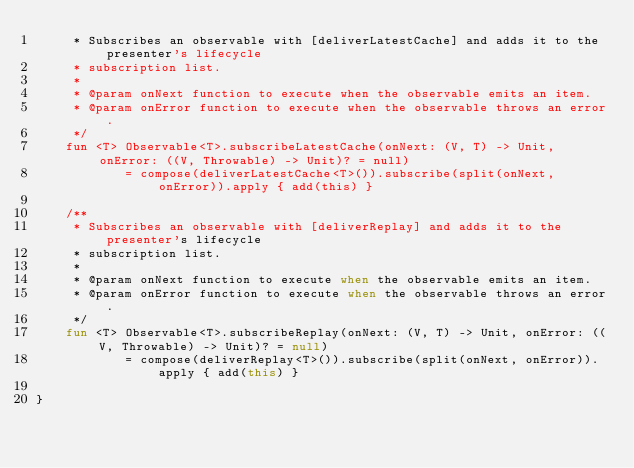Convert code to text. <code><loc_0><loc_0><loc_500><loc_500><_Kotlin_>     * Subscribes an observable with [deliverLatestCache] and adds it to the presenter's lifecycle
     * subscription list.
     *
     * @param onNext function to execute when the observable emits an item.
     * @param onError function to execute when the observable throws an error.
     */
    fun <T> Observable<T>.subscribeLatestCache(onNext: (V, T) -> Unit, onError: ((V, Throwable) -> Unit)? = null)
            = compose(deliverLatestCache<T>()).subscribe(split(onNext, onError)).apply { add(this) }

    /**
     * Subscribes an observable with [deliverReplay] and adds it to the presenter's lifecycle
     * subscription list.
     *
     * @param onNext function to execute when the observable emits an item.
     * @param onError function to execute when the observable throws an error.
     */
    fun <T> Observable<T>.subscribeReplay(onNext: (V, T) -> Unit, onError: ((V, Throwable) -> Unit)? = null)
            = compose(deliverReplay<T>()).subscribe(split(onNext, onError)).apply { add(this) }

}
</code> 